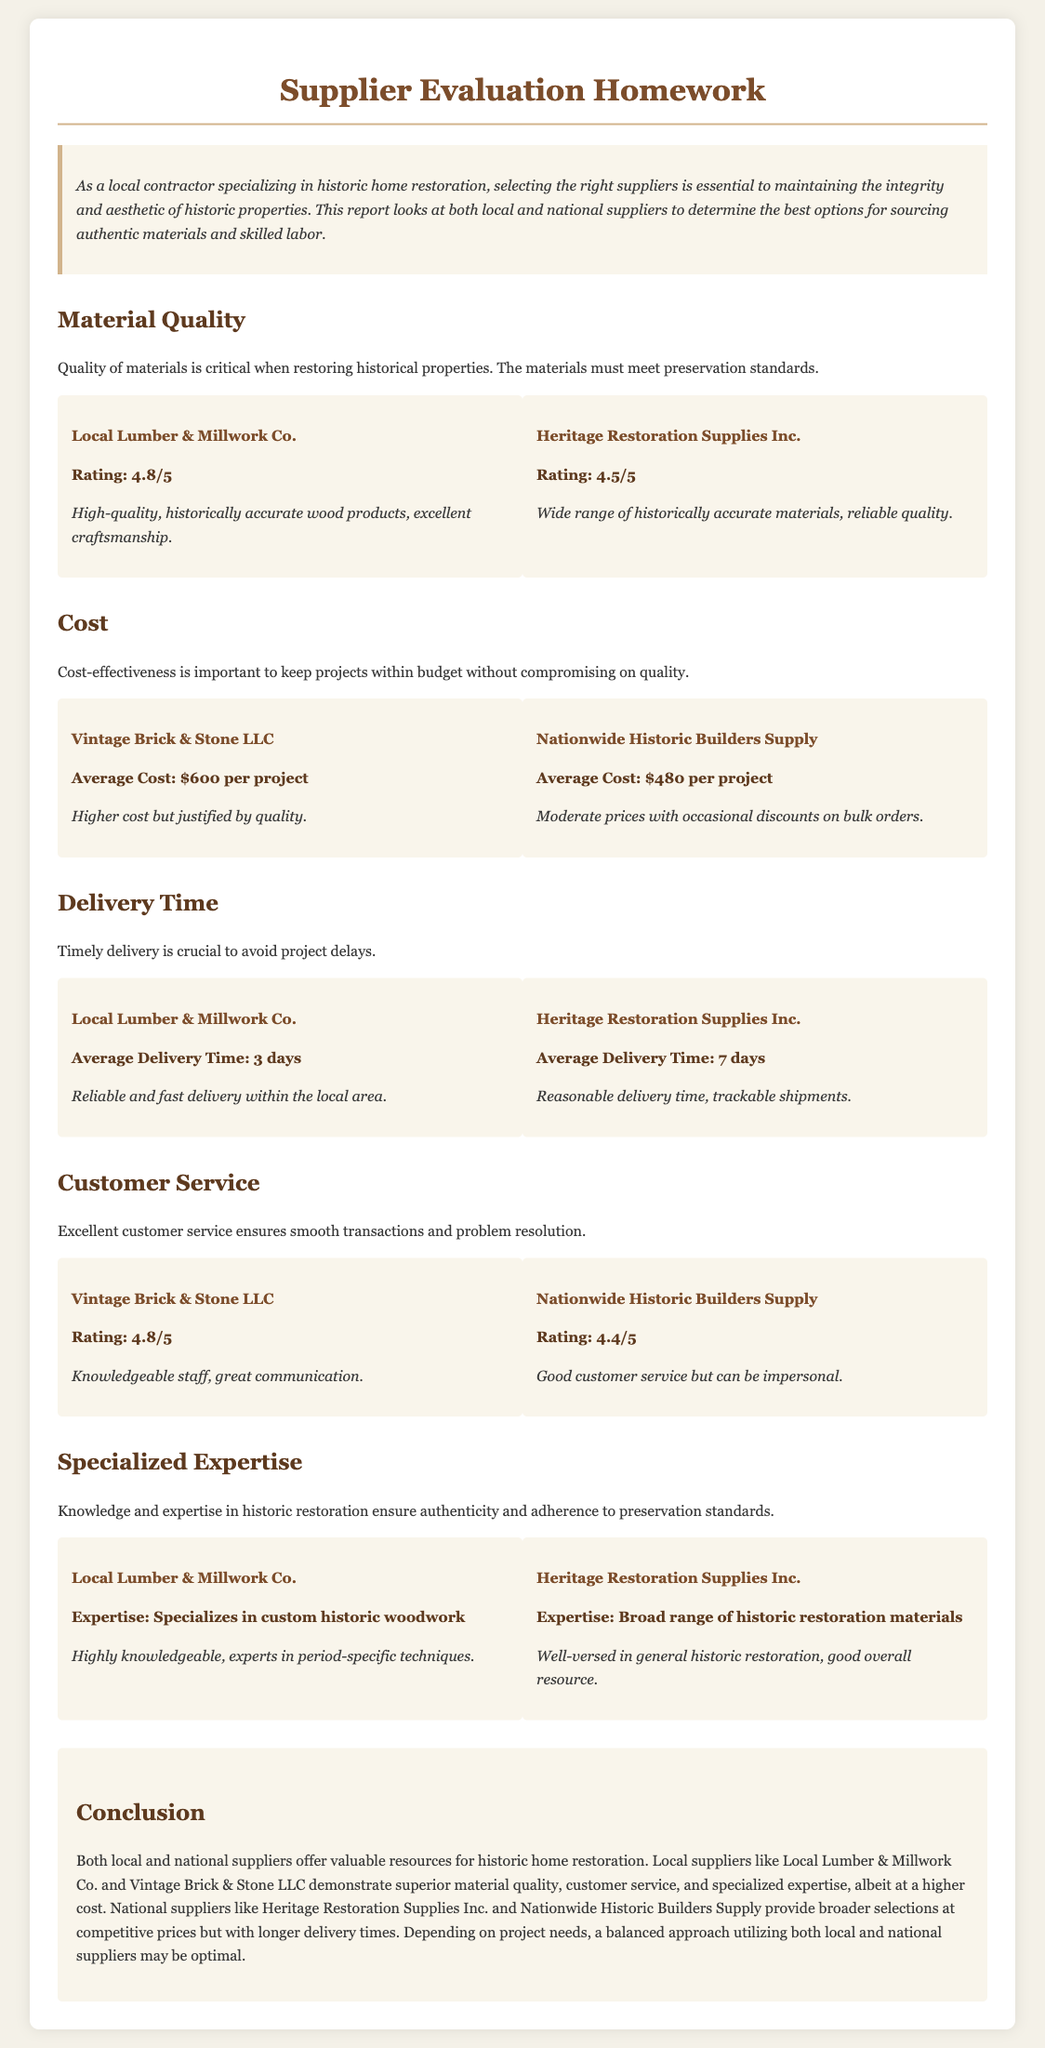what is the rating of Local Lumber & Millwork Co.? The rating is mentioned under the Material Quality section for Local Lumber & Millwork Co.
Answer: 4.8/5 what is the average cost for Nationwide Historic Builders Supply? The average cost is specified in the Cost section for Nationwide Historic Builders Supply.
Answer: $480 per project what is the average delivery time for Heritage Restoration Supplies Inc.? The average delivery time is noted in the Delivery Time section for Heritage Restoration Supplies Inc.
Answer: 7 days which supplier specializes in custom historic woodwork? The specialization is highlighted in the Specialized Expertise section.
Answer: Local Lumber & Millwork Co what is the feedback for Vintage Brick & Stone LLC's customer service? The feedback is provided in the Customer Service section regarding their performance.
Answer: Knowledgeable staff, great communication which supplier has a lower material quality rating, Heritage Restoration Supplies Inc. or Local Lumber & Millwork Co.? The comparison requires evaluating the ratings from the Material Quality section for both suppliers.
Answer: Heritage Restoration Supplies Inc which aspect is emphasized as crucial for historic home restoration? This aspect is discussed in the introduction and sections of the document.
Answer: Material Quality what is the main conclusion regarding local and national suppliers? The conclusion recaps key insights about both local and national suppliers.
Answer: A balanced approach utilizing both may be optimal 